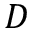Convert formula to latex. <formula><loc_0><loc_0><loc_500><loc_500>D</formula> 